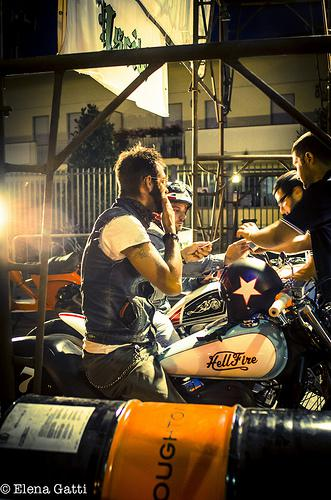Question: where is the middle man's tattoo?
Choices:
A. On his chest.
B. On his leg.
C. On his face.
D. On his arm.
Answer with the letter. Answer: D Question: how many men are there?
Choices:
A. 3.
B. 5.
C. 4.
D. 6.
Answer with the letter. Answer: C Question: when was the picture taken?
Choices:
A. At night.
B. In the morning.
C. In the afternoon.
D. At 2:00.
Answer with the letter. Answer: A Question: what is the word on the motorcycle?
Choices:
A. HellFire.
B. Angels.
C. Mean guys.
D. Tough.
Answer with the letter. Answer: A 